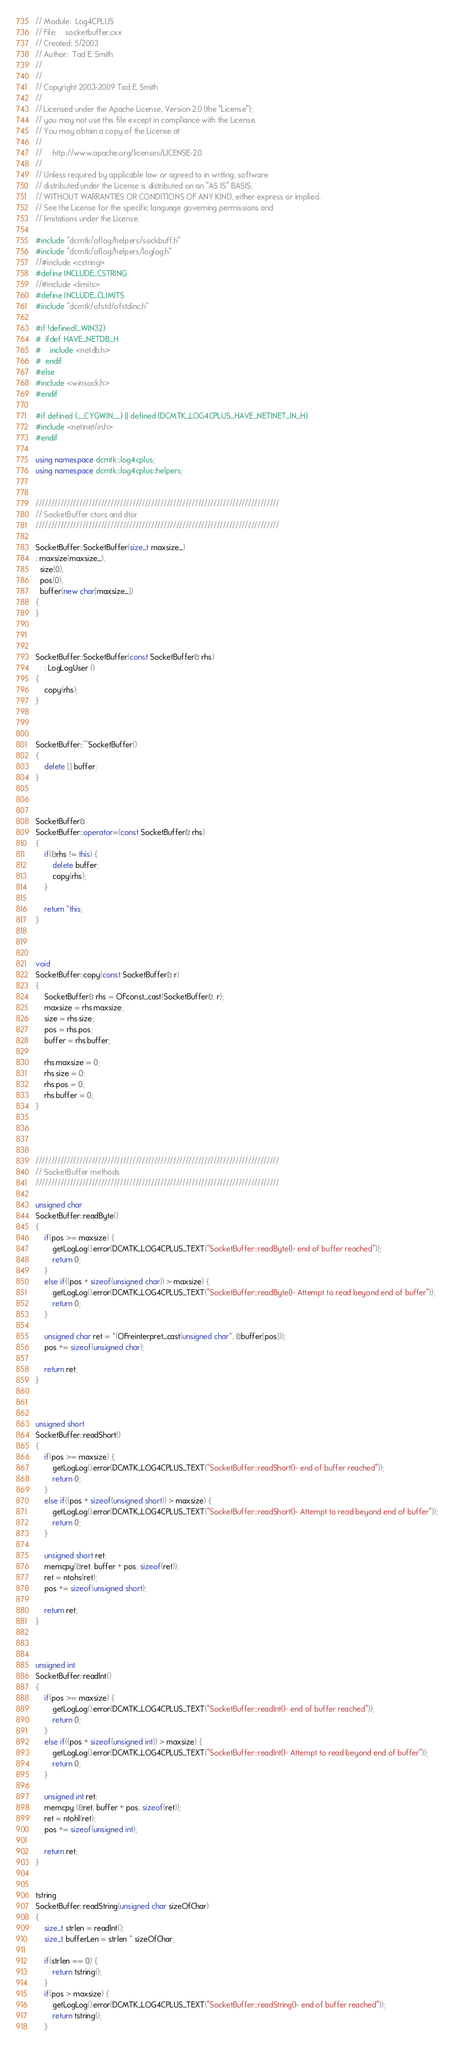<code> <loc_0><loc_0><loc_500><loc_500><_C++_>// Module:  Log4CPLUS
// File:    socketbuffer.cxx
// Created: 5/2003
// Author:  Tad E. Smith
//
//
// Copyright 2003-2009 Tad E. Smith
//
// Licensed under the Apache License, Version 2.0 (the "License");
// you may not use this file except in compliance with the License.
// You may obtain a copy of the License at
//
//     http://www.apache.org/licenses/LICENSE-2.0
//
// Unless required by applicable law or agreed to in writing, software
// distributed under the License is distributed on an "AS IS" BASIS,
// WITHOUT WARRANTIES OR CONDITIONS OF ANY KIND, either express or implied.
// See the License for the specific language governing permissions and
// limitations under the License.

#include "dcmtk/oflog/helpers/sockbuff.h"
#include "dcmtk/oflog/helpers/loglog.h"
//#include <cstring>
#define INCLUDE_CSTRING
//#include <limits>
#define INCLUDE_CLIMITS
#include "dcmtk/ofstd/ofstdinc.h"

#if !defined(_WIN32)
#  ifdef HAVE_NETDB_H
#    include <netdb.h>
#  endif
#else
#include <winsock.h>
#endif

#if defined (__CYGWIN__) || defined (DCMTK_LOG4CPLUS_HAVE_NETINET_IN_H)
#include <netinet/in.h>
#endif

using namespace dcmtk::log4cplus;
using namespace dcmtk::log4cplus::helpers;


//////////////////////////////////////////////////////////////////////////////
// SocketBuffer ctors and dtor
//////////////////////////////////////////////////////////////////////////////

SocketBuffer::SocketBuffer(size_t maxsize_)
: maxsize(maxsize_),
  size(0),
  pos(0),
  buffer(new char[maxsize_])
{
}



SocketBuffer::SocketBuffer(const SocketBuffer& rhs)
    : LogLogUser ()
{
    copy(rhs);
}



SocketBuffer::~SocketBuffer()
{
    delete [] buffer;
}



SocketBuffer&
SocketBuffer::operator=(const SocketBuffer& rhs)
{
    if(&rhs != this) {
        delete buffer;
        copy(rhs);
    }

    return *this;
}



void
SocketBuffer::copy(const SocketBuffer& r)
{
    SocketBuffer& rhs = OFconst_cast(SocketBuffer&, r);
    maxsize = rhs.maxsize;
    size = rhs.size;
    pos = rhs.pos;
    buffer = rhs.buffer;

    rhs.maxsize = 0;
    rhs.size = 0;
    rhs.pos = 0;
    rhs.buffer = 0;
}




//////////////////////////////////////////////////////////////////////////////
// SocketBuffer methods
//////////////////////////////////////////////////////////////////////////////

unsigned char
SocketBuffer::readByte()
{
    if(pos >= maxsize) {
        getLogLog().error(DCMTK_LOG4CPLUS_TEXT("SocketBuffer::readByte()- end of buffer reached"));
        return 0;
    }
    else if((pos + sizeof(unsigned char)) > maxsize) {
        getLogLog().error(DCMTK_LOG4CPLUS_TEXT("SocketBuffer::readByte()- Attempt to read beyond end of buffer"));
        return 0;
    }

    unsigned char ret = *(OFreinterpret_cast(unsigned char*, &buffer[pos]));
    pos += sizeof(unsigned char);

    return ret;
}



unsigned short
SocketBuffer::readShort()
{
    if(pos >= maxsize) {
        getLogLog().error(DCMTK_LOG4CPLUS_TEXT("SocketBuffer::readShort()- end of buffer reached"));
        return 0;
    }
    else if((pos + sizeof(unsigned short)) > maxsize) {
        getLogLog().error(DCMTK_LOG4CPLUS_TEXT("SocketBuffer::readShort()- Attempt to read beyond end of buffer"));
        return 0;
    }

    unsigned short ret;
    memcpy(&ret, buffer + pos, sizeof(ret));
    ret = ntohs(ret);
    pos += sizeof(unsigned short);

    return ret;
}



unsigned int
SocketBuffer::readInt()
{
    if(pos >= maxsize) {
        getLogLog().error(DCMTK_LOG4CPLUS_TEXT("SocketBuffer::readInt()- end of buffer reached"));
        return 0;
    }
    else if((pos + sizeof(unsigned int)) > maxsize) {
        getLogLog().error(DCMTK_LOG4CPLUS_TEXT("SocketBuffer::readInt()- Attempt to read beyond end of buffer"));
        return 0;
    }

    unsigned int ret;
    memcpy (&ret, buffer + pos, sizeof(ret));
    ret = ntohl(ret);
    pos += sizeof(unsigned int);

    return ret;
}


tstring
SocketBuffer::readString(unsigned char sizeOfChar)
{
    size_t strlen = readInt();
    size_t bufferLen = strlen * sizeOfChar;

    if(strlen == 0) {
        return tstring();
    }
    if(pos > maxsize) {
        getLogLog().error(DCMTK_LOG4CPLUS_TEXT("SocketBuffer::readString()- end of buffer reached"));
        return tstring();
    }
</code> 